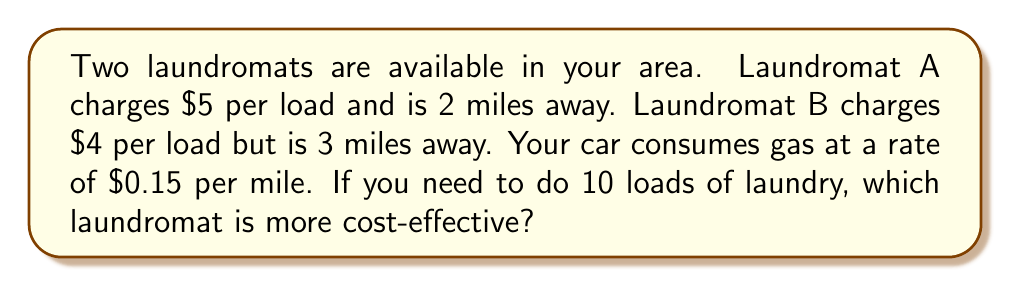Show me your answer to this math problem. Let's break this down step-by-step:

1) First, calculate the cost of laundry at each location:
   Laundromat A: $5 * 10 loads = $50
   Laundromat B: $4 * 10 loads = $40

2) Now, calculate the transportation cost for each option:
   Laundromat A: 2 miles * 2 (round trip) * $0.15 per mile = $0.60
   Laundromat B: 3 miles * 2 (round trip) * $0.15 per mile = $0.90

3) Total cost for each option:
   Laundromat A: $50 + $0.60 = $50.60
   Laundromat B: $40 + $0.90 = $40.90

4) Compare the total costs:
   $$50.60 - 40.90 = 9.70$$

Laundromat B is $9.70 cheaper than Laundromat A.

Therefore, Laundromat B is more cost-effective despite being further away.
Answer: Laundromat B 